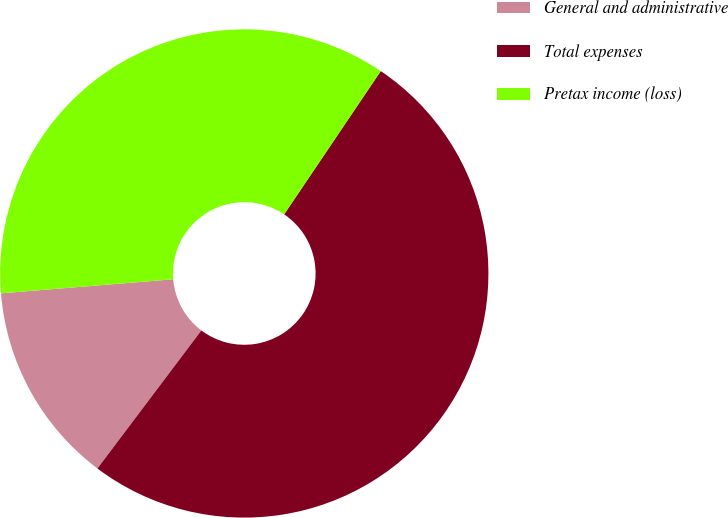Convert chart to OTSL. <chart><loc_0><loc_0><loc_500><loc_500><pie_chart><fcel>General and administrative<fcel>Total expenses<fcel>Pretax income (loss)<nl><fcel>13.43%<fcel>50.83%<fcel>35.74%<nl></chart> 